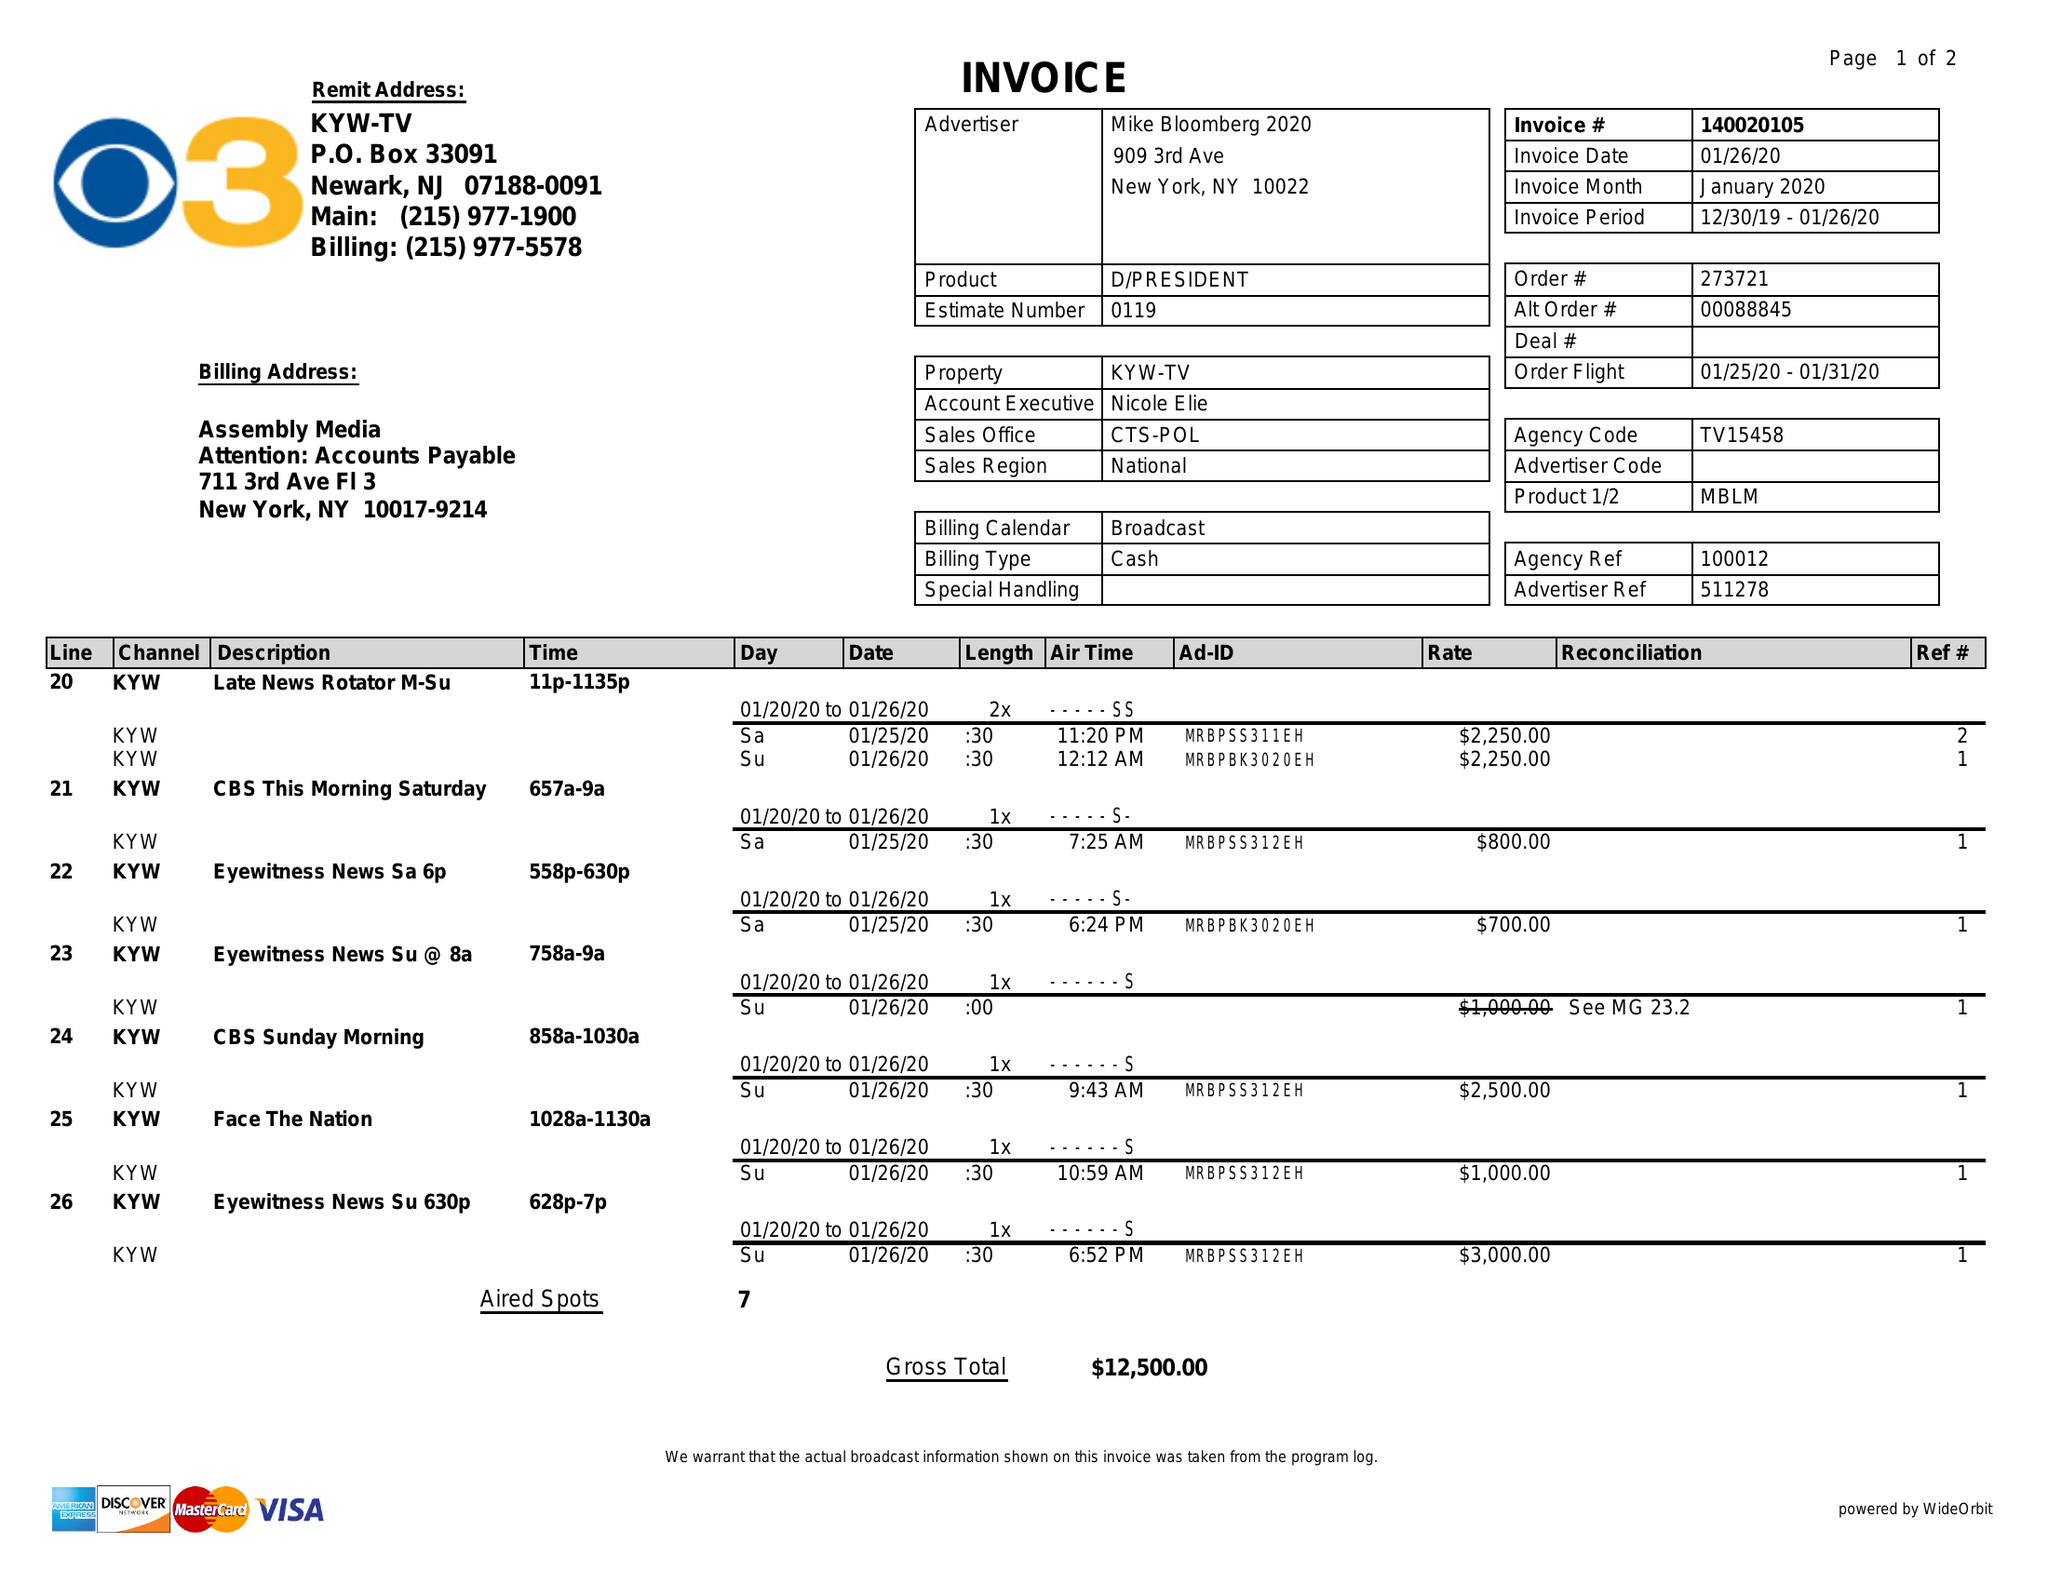What is the value for the flight_to?
Answer the question using a single word or phrase. 01/31/20 